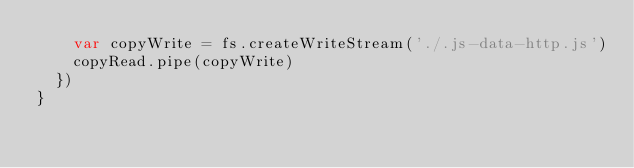Convert code to text. <code><loc_0><loc_0><loc_500><loc_500><_JavaScript_>    var copyWrite = fs.createWriteStream('./.js-data-http.js')
    copyRead.pipe(copyWrite)
  })
}
</code> 